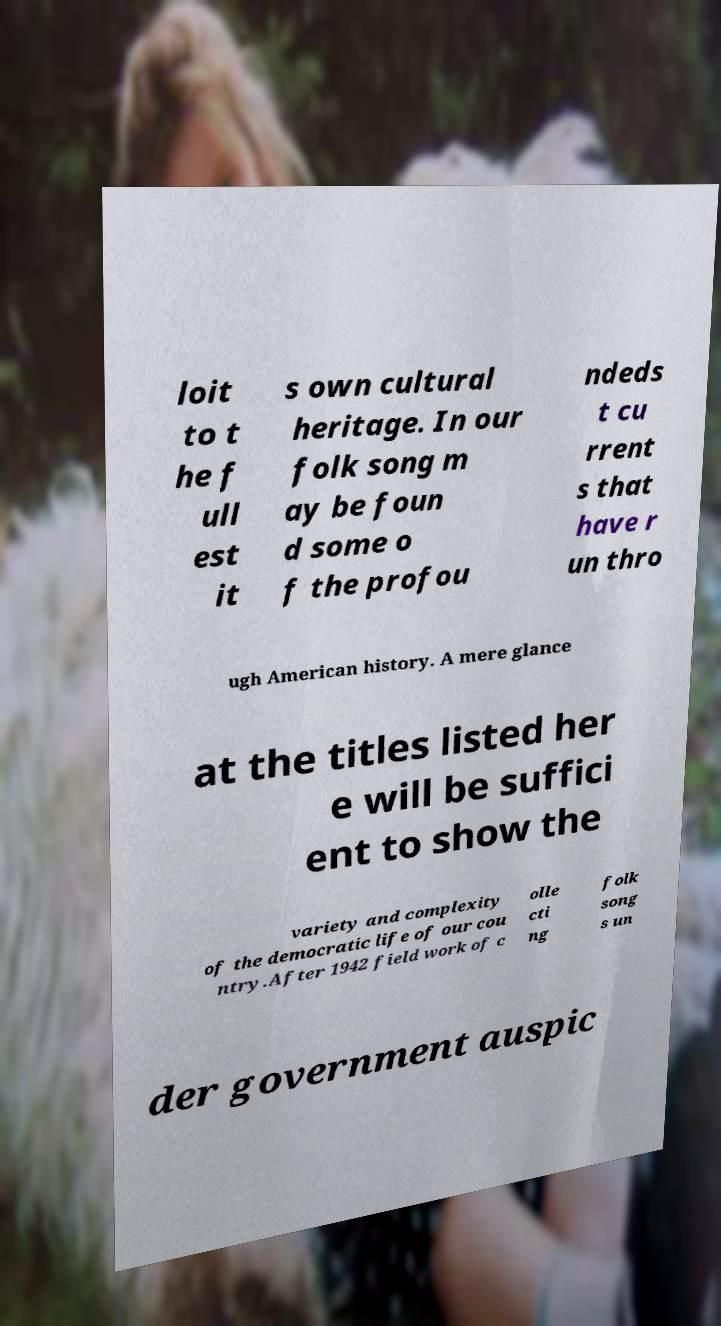Please identify and transcribe the text found in this image. loit to t he f ull est it s own cultural heritage. In our folk song m ay be foun d some o f the profou ndeds t cu rrent s that have r un thro ugh American history. A mere glance at the titles listed her e will be suffici ent to show the variety and complexity of the democratic life of our cou ntry.After 1942 field work of c olle cti ng folk song s un der government auspic 